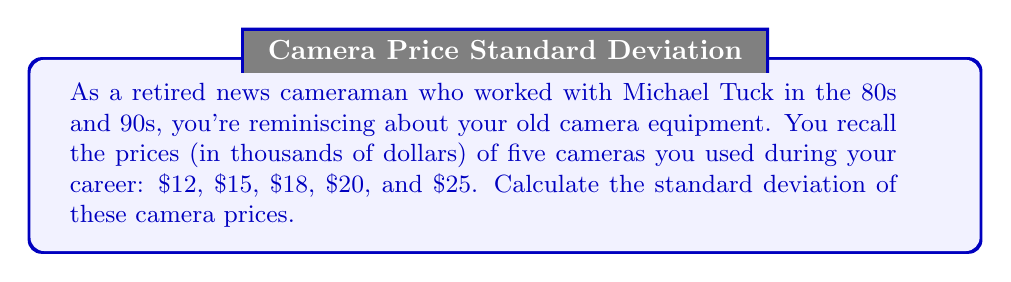Provide a solution to this math problem. To calculate the standard deviation, we'll follow these steps:

1. Calculate the mean (average) of the prices:
   $\bar{x} = \frac{12 + 15 + 18 + 20 + 25}{5} = \frac{90}{5} = 18$

2. Calculate the squared differences from the mean:
   $(12 - 18)^2 = (-6)^2 = 36$
   $(15 - 18)^2 = (-3)^2 = 9$
   $(18 - 18)^2 = 0^2 = 0$
   $(20 - 18)^2 = 2^2 = 4$
   $(25 - 18)^2 = 7^2 = 49$

3. Calculate the average of the squared differences:
   $\frac{36 + 9 + 0 + 4 + 49}{5} = \frac{98}{5} = 19.6$

4. Take the square root of the result from step 3:
   $\sqrt{19.6} = 4.427$

The formula for standard deviation is:

$$s = \sqrt{\frac{\sum_{i=1}^{n} (x_i - \bar{x})^2}{n}}$$

Where $s$ is the standard deviation, $x_i$ are the individual values, $\bar{x}$ is the mean, and $n$ is the number of values.
Answer: $4.427$ thousand dollars 